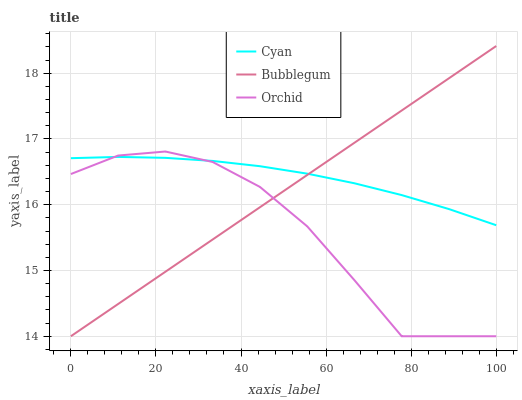Does Orchid have the minimum area under the curve?
Answer yes or no. Yes. Does Cyan have the maximum area under the curve?
Answer yes or no. Yes. Does Bubblegum have the minimum area under the curve?
Answer yes or no. No. Does Bubblegum have the maximum area under the curve?
Answer yes or no. No. Is Bubblegum the smoothest?
Answer yes or no. Yes. Is Orchid the roughest?
Answer yes or no. Yes. Is Orchid the smoothest?
Answer yes or no. No. Is Bubblegum the roughest?
Answer yes or no. No. Does Bubblegum have the lowest value?
Answer yes or no. Yes. Does Bubblegum have the highest value?
Answer yes or no. Yes. Does Orchid have the highest value?
Answer yes or no. No. Does Bubblegum intersect Cyan?
Answer yes or no. Yes. Is Bubblegum less than Cyan?
Answer yes or no. No. Is Bubblegum greater than Cyan?
Answer yes or no. No. 